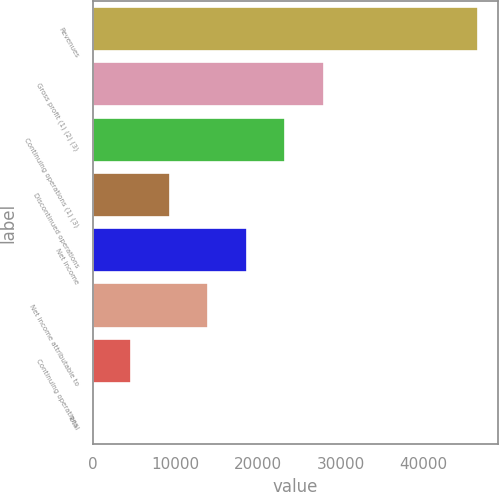Convert chart. <chart><loc_0><loc_0><loc_500><loc_500><bar_chart><fcel>Revenues<fcel>Gross profit (1) (2) (3)<fcel>Continuing operations (1) (3)<fcel>Discontinued operations<fcel>Net income<fcel>Net income attributable to<fcel>Continuing operations<fcel>Total<nl><fcel>46678<fcel>28007.5<fcel>23339.9<fcel>9337.1<fcel>18672.3<fcel>14004.7<fcel>4669.49<fcel>1.88<nl></chart> 